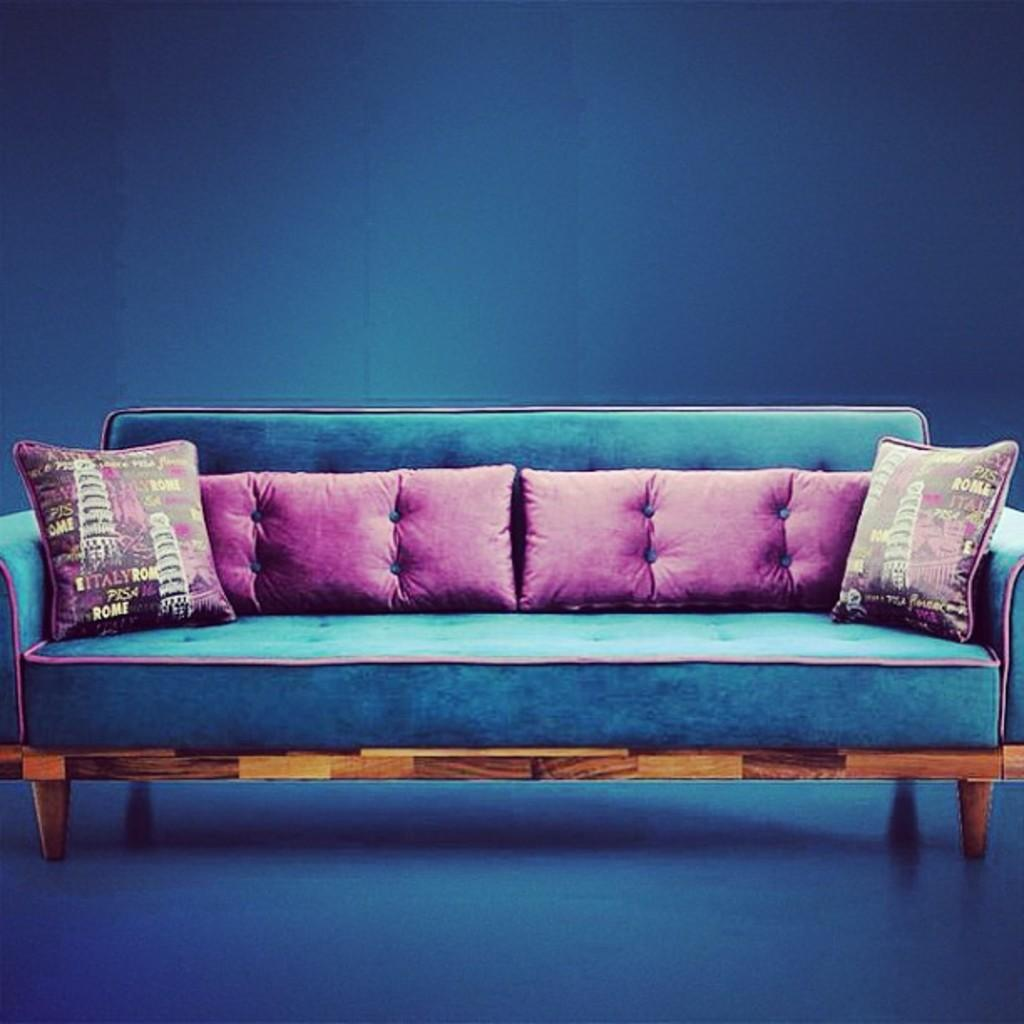What type of furniture is in the image? There is a sofa in the image. How many pillows are on the sofa? The sofa has four pillows on it. What color is the wall in the background of the image? There is a blue color wall in the background of the image. What type of magic spell is being cast on the sofa in the image? There is no magic spell or any indication of magic in the image; it simply shows a sofa with four pillows on it and a blue wall in the background. 